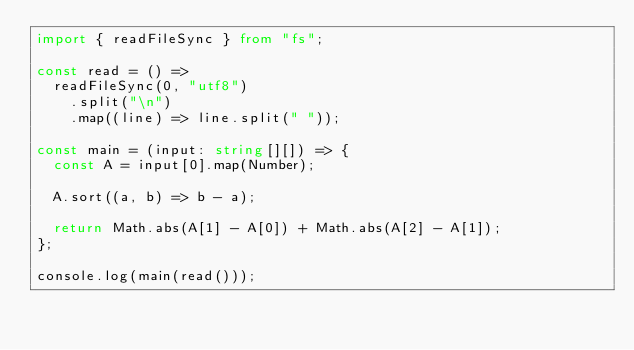Convert code to text. <code><loc_0><loc_0><loc_500><loc_500><_TypeScript_>import { readFileSync } from "fs";

const read = () =>
  readFileSync(0, "utf8")
    .split("\n")
    .map((line) => line.split(" "));

const main = (input: string[][]) => {
  const A = input[0].map(Number);

  A.sort((a, b) => b - a);

  return Math.abs(A[1] - A[0]) + Math.abs(A[2] - A[1]);
};

console.log(main(read()));
</code> 